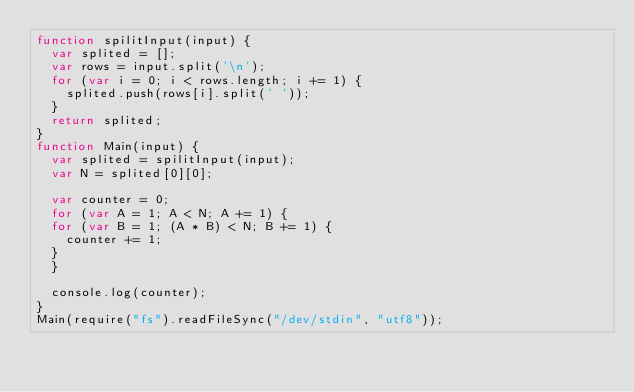<code> <loc_0><loc_0><loc_500><loc_500><_JavaScript_>function spilitInput(input) {
  var splited = [];
  var rows = input.split('\n');
  for (var i = 0; i < rows.length; i += 1) {
    splited.push(rows[i].split(' '));
  }
  return splited;
}
function Main(input) {
  var splited = spilitInput(input);
  var N = splited[0][0];
  
  var counter = 0;
  for (var A = 1; A < N; A += 1) {
  for (var B = 1; (A * B) < N; B += 1) {
    counter += 1;
  }
  }

  console.log(counter);
}
Main(require("fs").readFileSync("/dev/stdin", "utf8"));</code> 